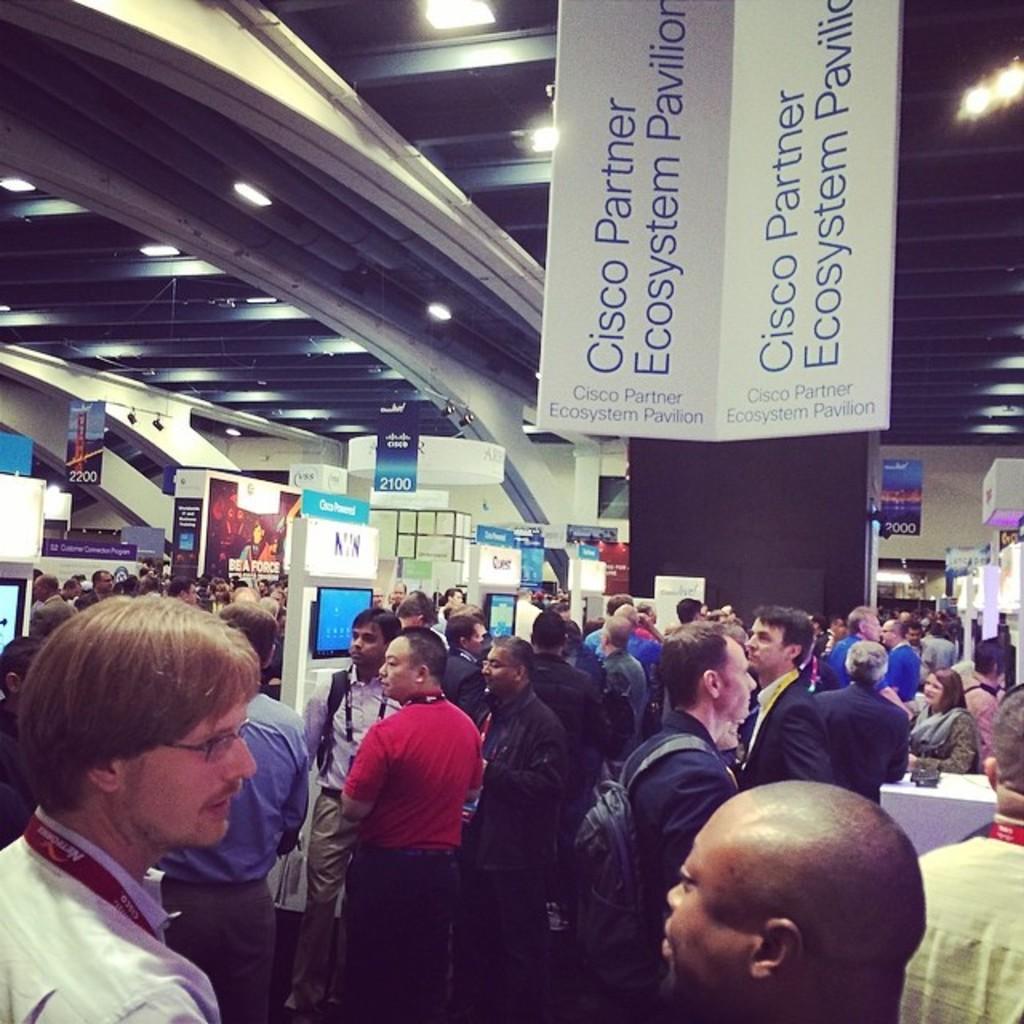Can you describe this image briefly? In the image we can see there are people standing and there are tv screens on the wall. There are banners hanging from the top and there are lights on the roof. 